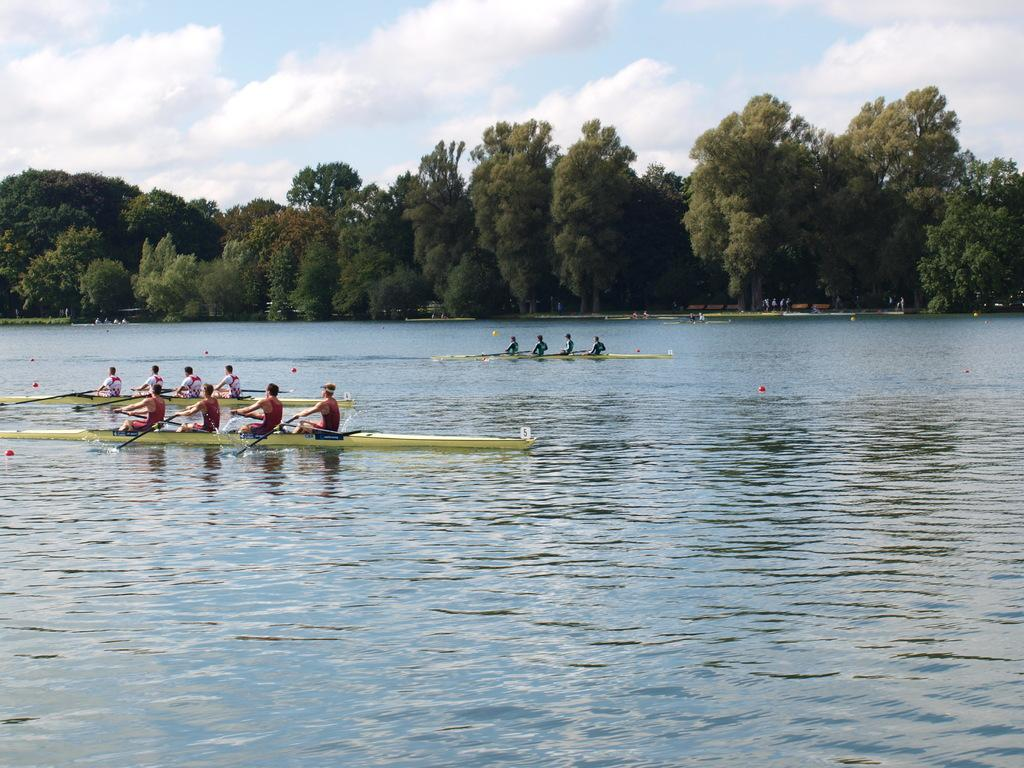What is the primary element in the image? There is water in the image. What is on the water? There are boats on the water. Who is in the boats? People are sitting in the boats. What can be seen in the background of the image? There are trees and the sky visible in the background of the image. How many things does the father give to the women in the image? There is no father or women present in the image, so it is not possible to answer that question. 